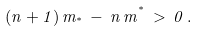Convert formula to latex. <formula><loc_0><loc_0><loc_500><loc_500>( n + 1 ) \, m _ { ^ { * } } \, - \, n \, m ^ { ^ { * } } \, > \, 0 \, .</formula> 